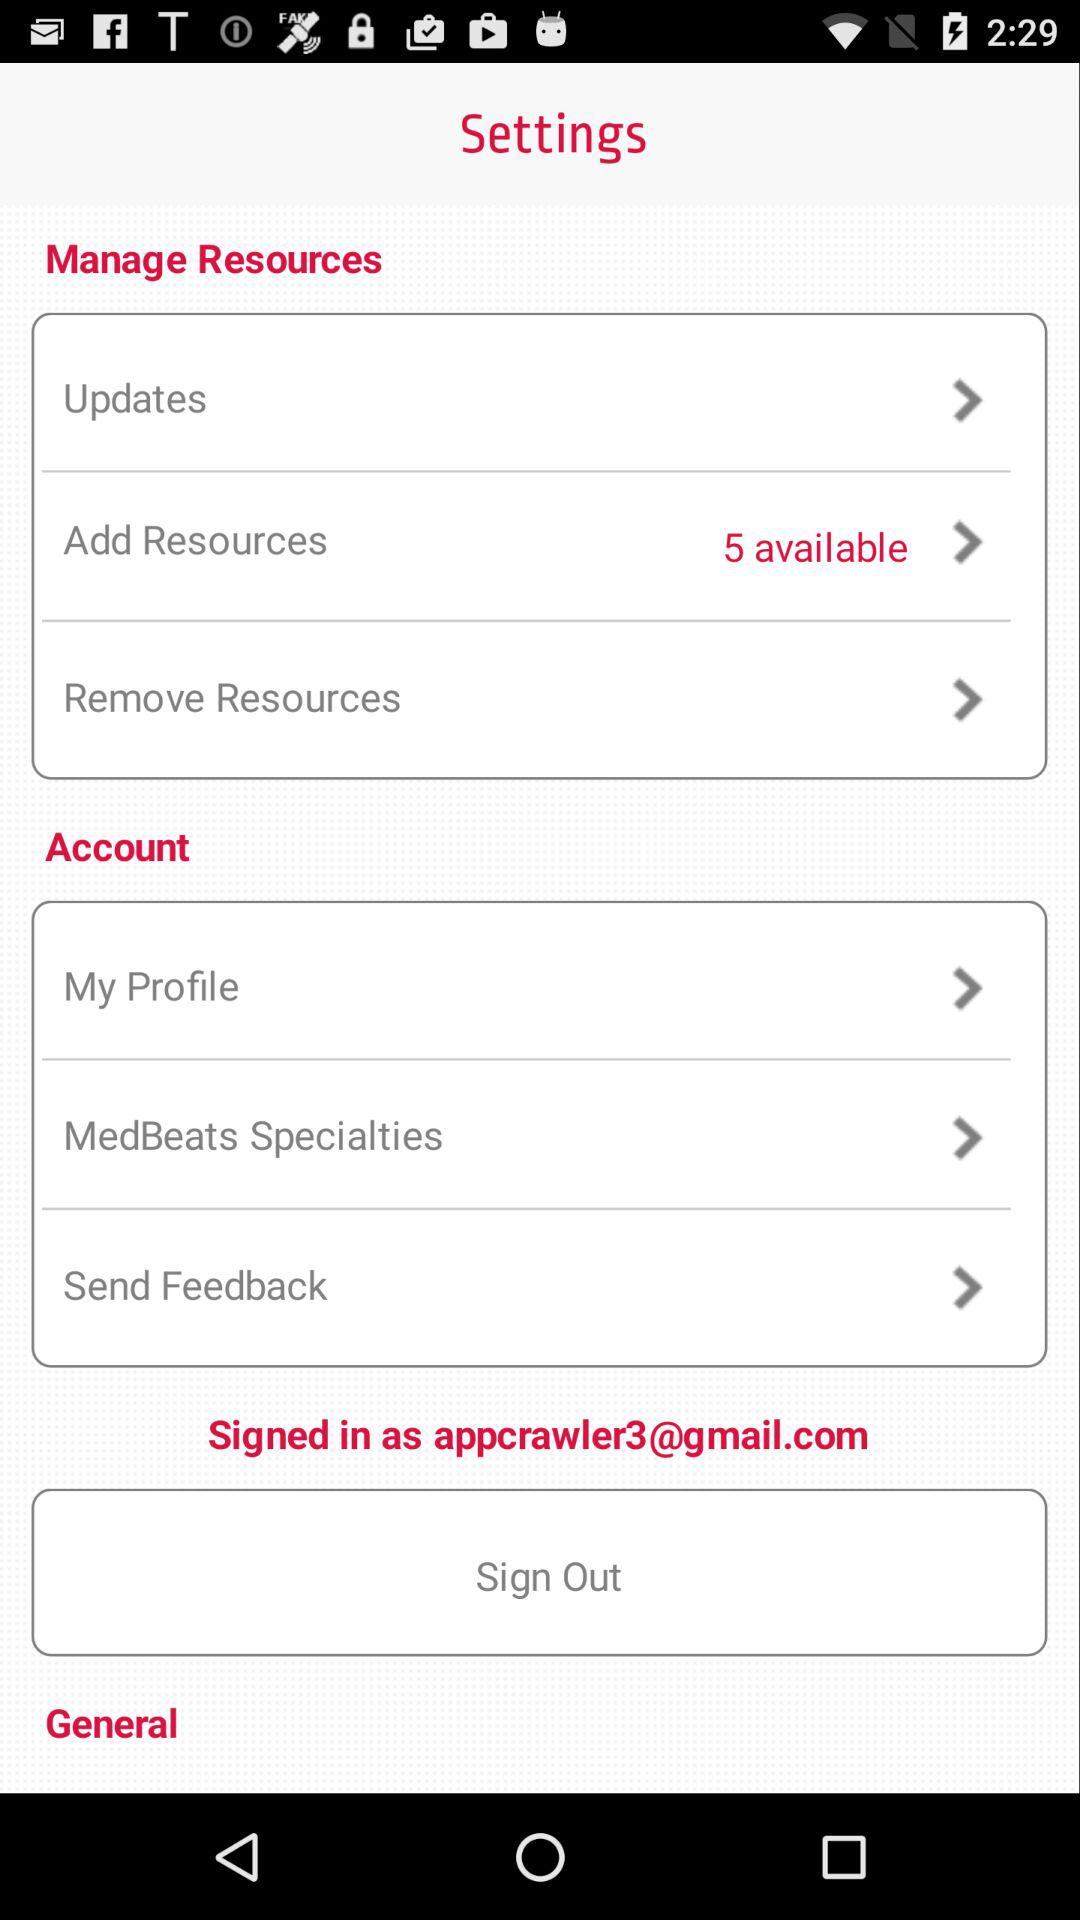How many items are in the Manage Resources section?
Answer the question using a single word or phrase. 3 